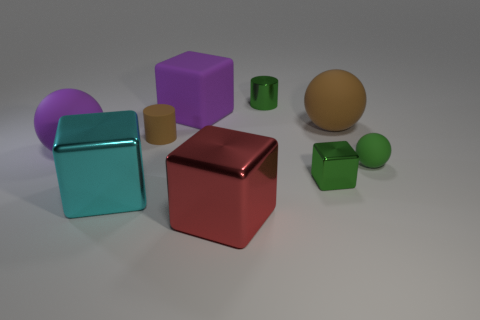Describe the lighting in this scene. The scene is softly illuminated with a general diffuse light, casting gentle shadows behind and to the right of the objects, suggesting a light source to the front-left of the scene. This kind of lighting creates soft-edged shadows and subtle highlights, giving the scene a calm and even tone. 